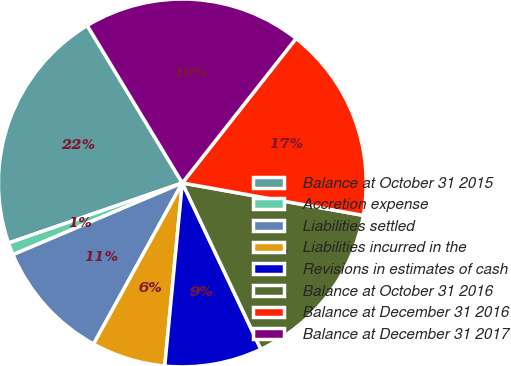Convert chart. <chart><loc_0><loc_0><loc_500><loc_500><pie_chart><fcel>Balance at October 31 2015<fcel>Accretion expense<fcel>Liabilities settled<fcel>Liabilities incurred in the<fcel>Revisions in estimates of cash<fcel>Balance at October 31 2016<fcel>Balance at December 31 2016<fcel>Balance at December 31 2017<nl><fcel>21.65%<fcel>1.08%<fcel>10.61%<fcel>6.49%<fcel>8.55%<fcel>15.15%<fcel>17.21%<fcel>19.26%<nl></chart> 